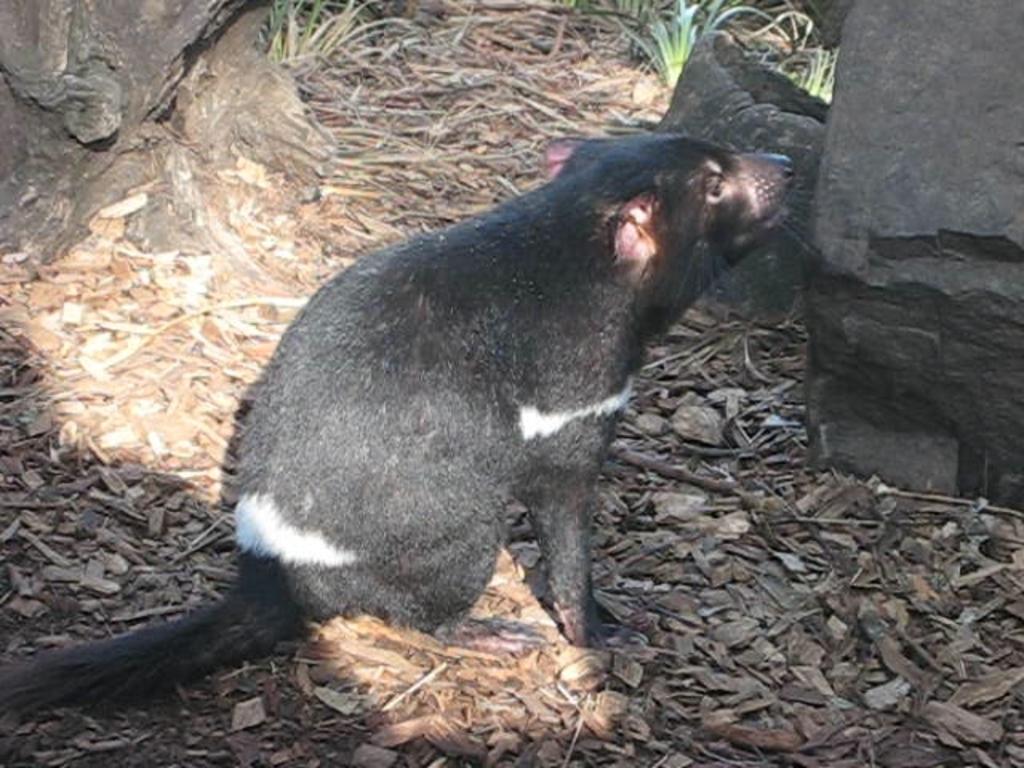In one or two sentences, can you explain what this image depicts? In this picture I can see in the middle there is an animal in black color, on the right side there are stones. At the top there are green plants. 